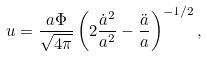Convert formula to latex. <formula><loc_0><loc_0><loc_500><loc_500>u = \frac { a \Phi } { \sqrt { 4 \pi } } \left ( 2 \frac { \dot { a } ^ { 2 } } { a ^ { 2 } } - \frac { \ddot { a } } { a } \right ) ^ { - 1 / 2 } ,</formula> 